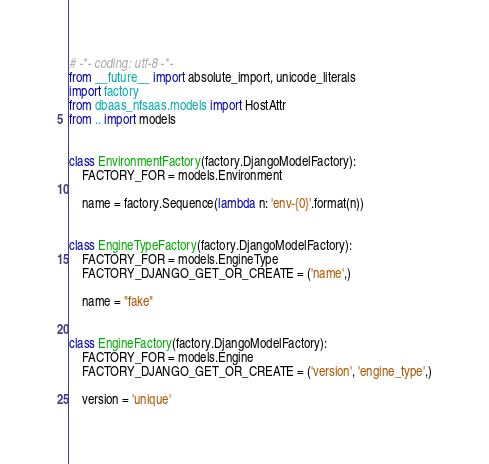Convert code to text. <code><loc_0><loc_0><loc_500><loc_500><_Python_># -*- coding: utf-8 -*-
from __future__ import absolute_import, unicode_literals
import factory
from dbaas_nfsaas.models import HostAttr
from .. import models


class EnvironmentFactory(factory.DjangoModelFactory):
    FACTORY_FOR = models.Environment

    name = factory.Sequence(lambda n: 'env-{0}'.format(n))


class EngineTypeFactory(factory.DjangoModelFactory):
    FACTORY_FOR = models.EngineType
    FACTORY_DJANGO_GET_OR_CREATE = ('name',)

    name = "fake"


class EngineFactory(factory.DjangoModelFactory):
    FACTORY_FOR = models.Engine
    FACTORY_DJANGO_GET_OR_CREATE = ('version', 'engine_type',)

    version = 'unique'</code> 